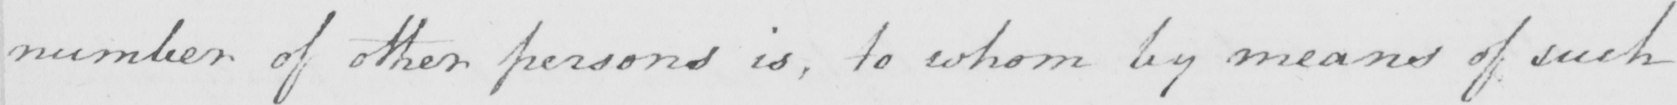Can you tell me what this handwritten text says? number of other persons is , to whom by means of such 